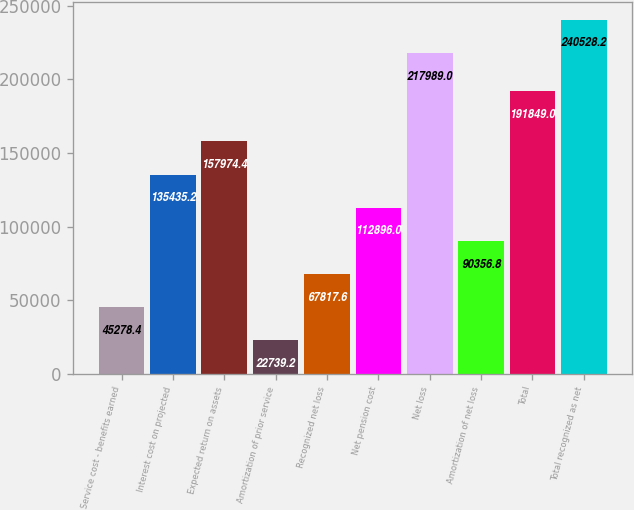<chart> <loc_0><loc_0><loc_500><loc_500><bar_chart><fcel>Service cost - benefits earned<fcel>Interest cost on projected<fcel>Expected return on assets<fcel>Amortization of prior service<fcel>Recognized net loss<fcel>Net pension cost<fcel>Net loss<fcel>Amortization of net loss<fcel>Total<fcel>Total recognized as net<nl><fcel>45278.4<fcel>135435<fcel>157974<fcel>22739.2<fcel>67817.6<fcel>112896<fcel>217989<fcel>90356.8<fcel>191849<fcel>240528<nl></chart> 